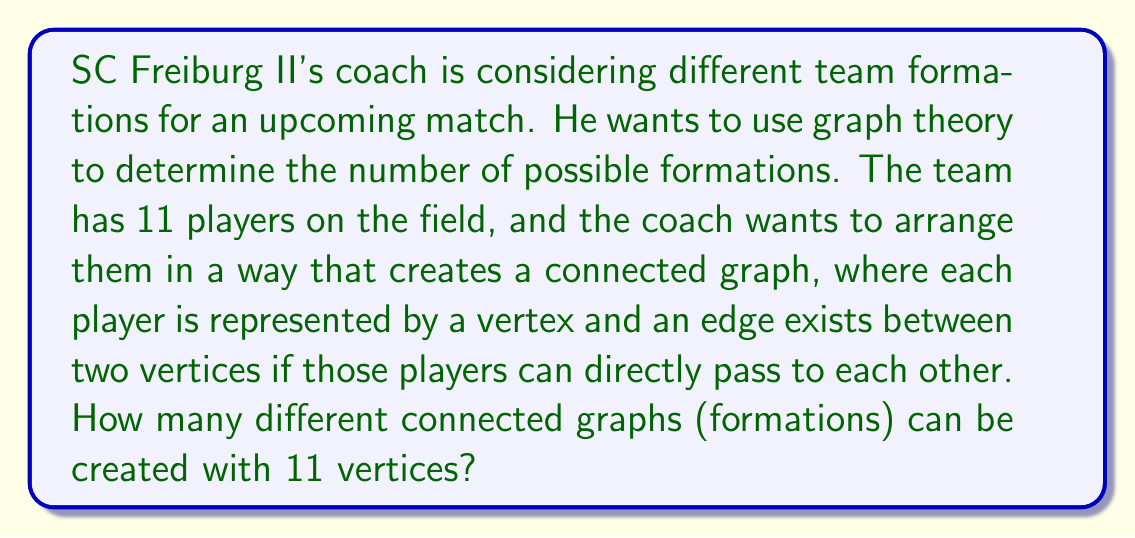Can you answer this question? To solve this problem, we need to use the concept of labeled trees in graph theory. Here's a step-by-step explanation:

1. In a football formation, all players need to be connected, forming a tree-like structure. This ensures that every player can reach any other player through a series of passes.

2. The number of different labeled trees with n vertices is given by Cayley's formula:
   
   $$T_n = n^{n-2}$$

   Where $T_n$ is the number of labeled trees and n is the number of vertices.

3. In our case, n = 11 (the number of players on the field).

4. Substituting this into Cayley's formula:

   $$T_{11} = 11^{11-2} = 11^9$$

5. Calculate $11^9$:
   
   $$11^9 = 2,357,947,691,$$

Therefore, there are 2,357,947,691 different possible connected graphs (formations) that can be created with 11 players.

Note: This calculation assumes that all players can potentially pass to all other players, which might not be strictly true in real football tactics. However, it provides an upper bound on the number of possible formations from a graph theory perspective.
Answer: $$2,357,947,691$$ 